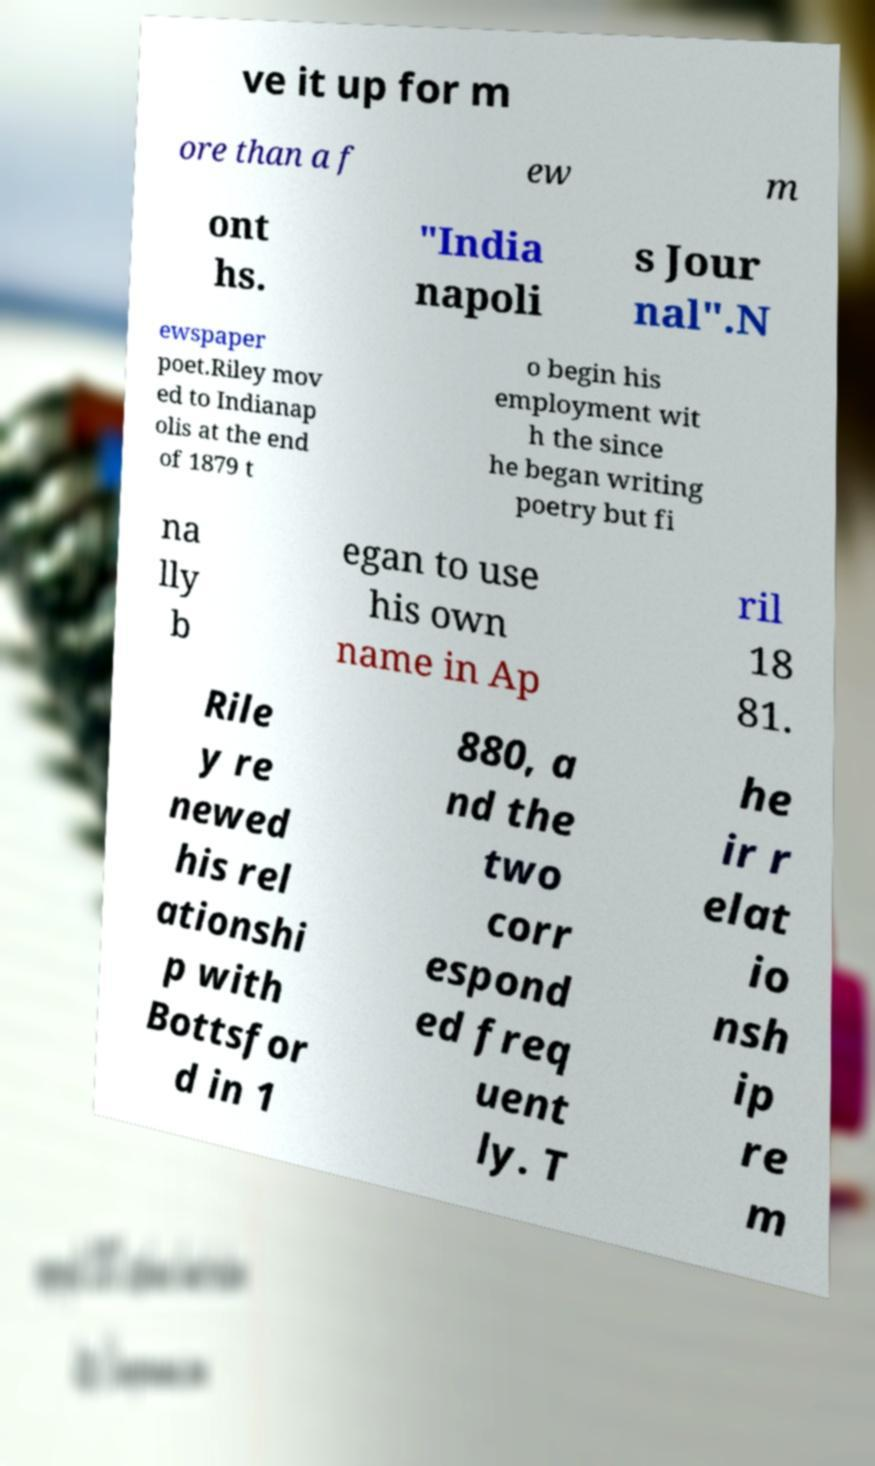Could you extract and type out the text from this image? ve it up for m ore than a f ew m ont hs. "India napoli s Jour nal".N ewspaper poet.Riley mov ed to Indianap olis at the end of 1879 t o begin his employment wit h the since he began writing poetry but fi na lly b egan to use his own name in Ap ril 18 81. Rile y re newed his rel ationshi p with Bottsfor d in 1 880, a nd the two corr espond ed freq uent ly. T he ir r elat io nsh ip re m 